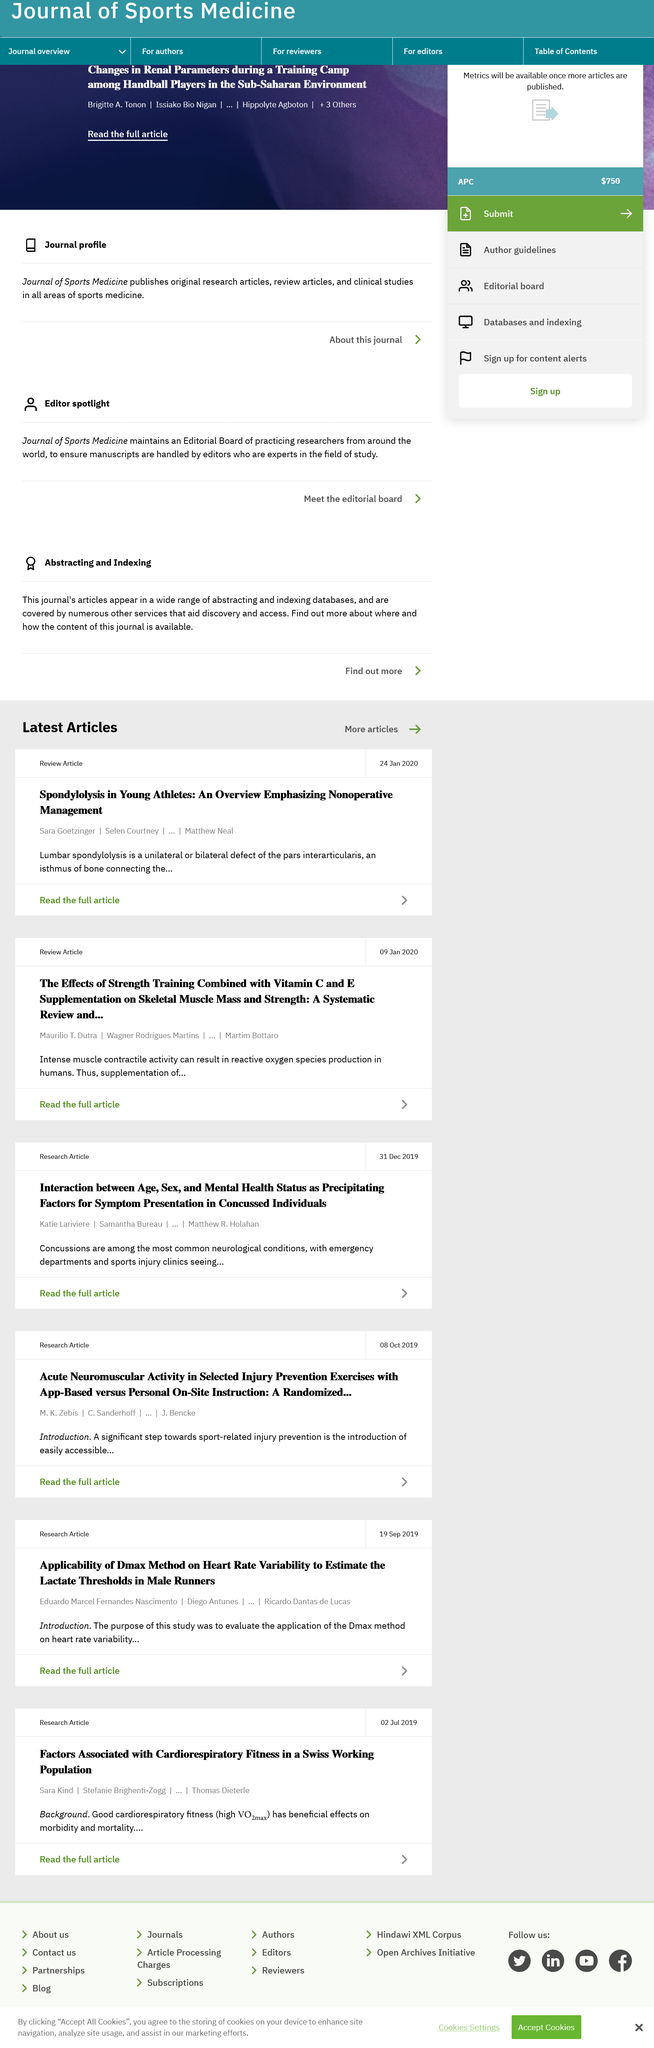Highlight a few significant elements in this photo. The supplementation of vitamin C and E has been found to impact strength training, with the result being a positive effect. Spondylolysis is a unilateral or bilateral defect of the pars interarticularis in the spine, which can affect young athletes. Intense muscle contractile activity can result in the production of reactive oxygen species in humans. 